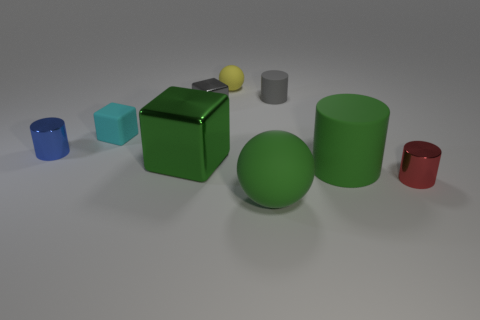Subtract 1 cylinders. How many cylinders are left? 3 Subtract all blue cylinders. How many cylinders are left? 3 Add 1 big green shiny cylinders. How many objects exist? 10 Subtract all blue cylinders. Subtract all purple blocks. How many cylinders are left? 3 Subtract all cylinders. How many objects are left? 5 Add 1 green metal objects. How many green metal objects are left? 2 Add 2 blue things. How many blue things exist? 3 Subtract 0 blue cubes. How many objects are left? 9 Subtract all big matte balls. Subtract all purple matte cylinders. How many objects are left? 8 